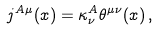Convert formula to latex. <formula><loc_0><loc_0><loc_500><loc_500>j ^ { A \mu } ( x ) = \kappa ^ { A } _ { \nu } \theta ^ { \mu \nu } ( x ) \, ,</formula> 